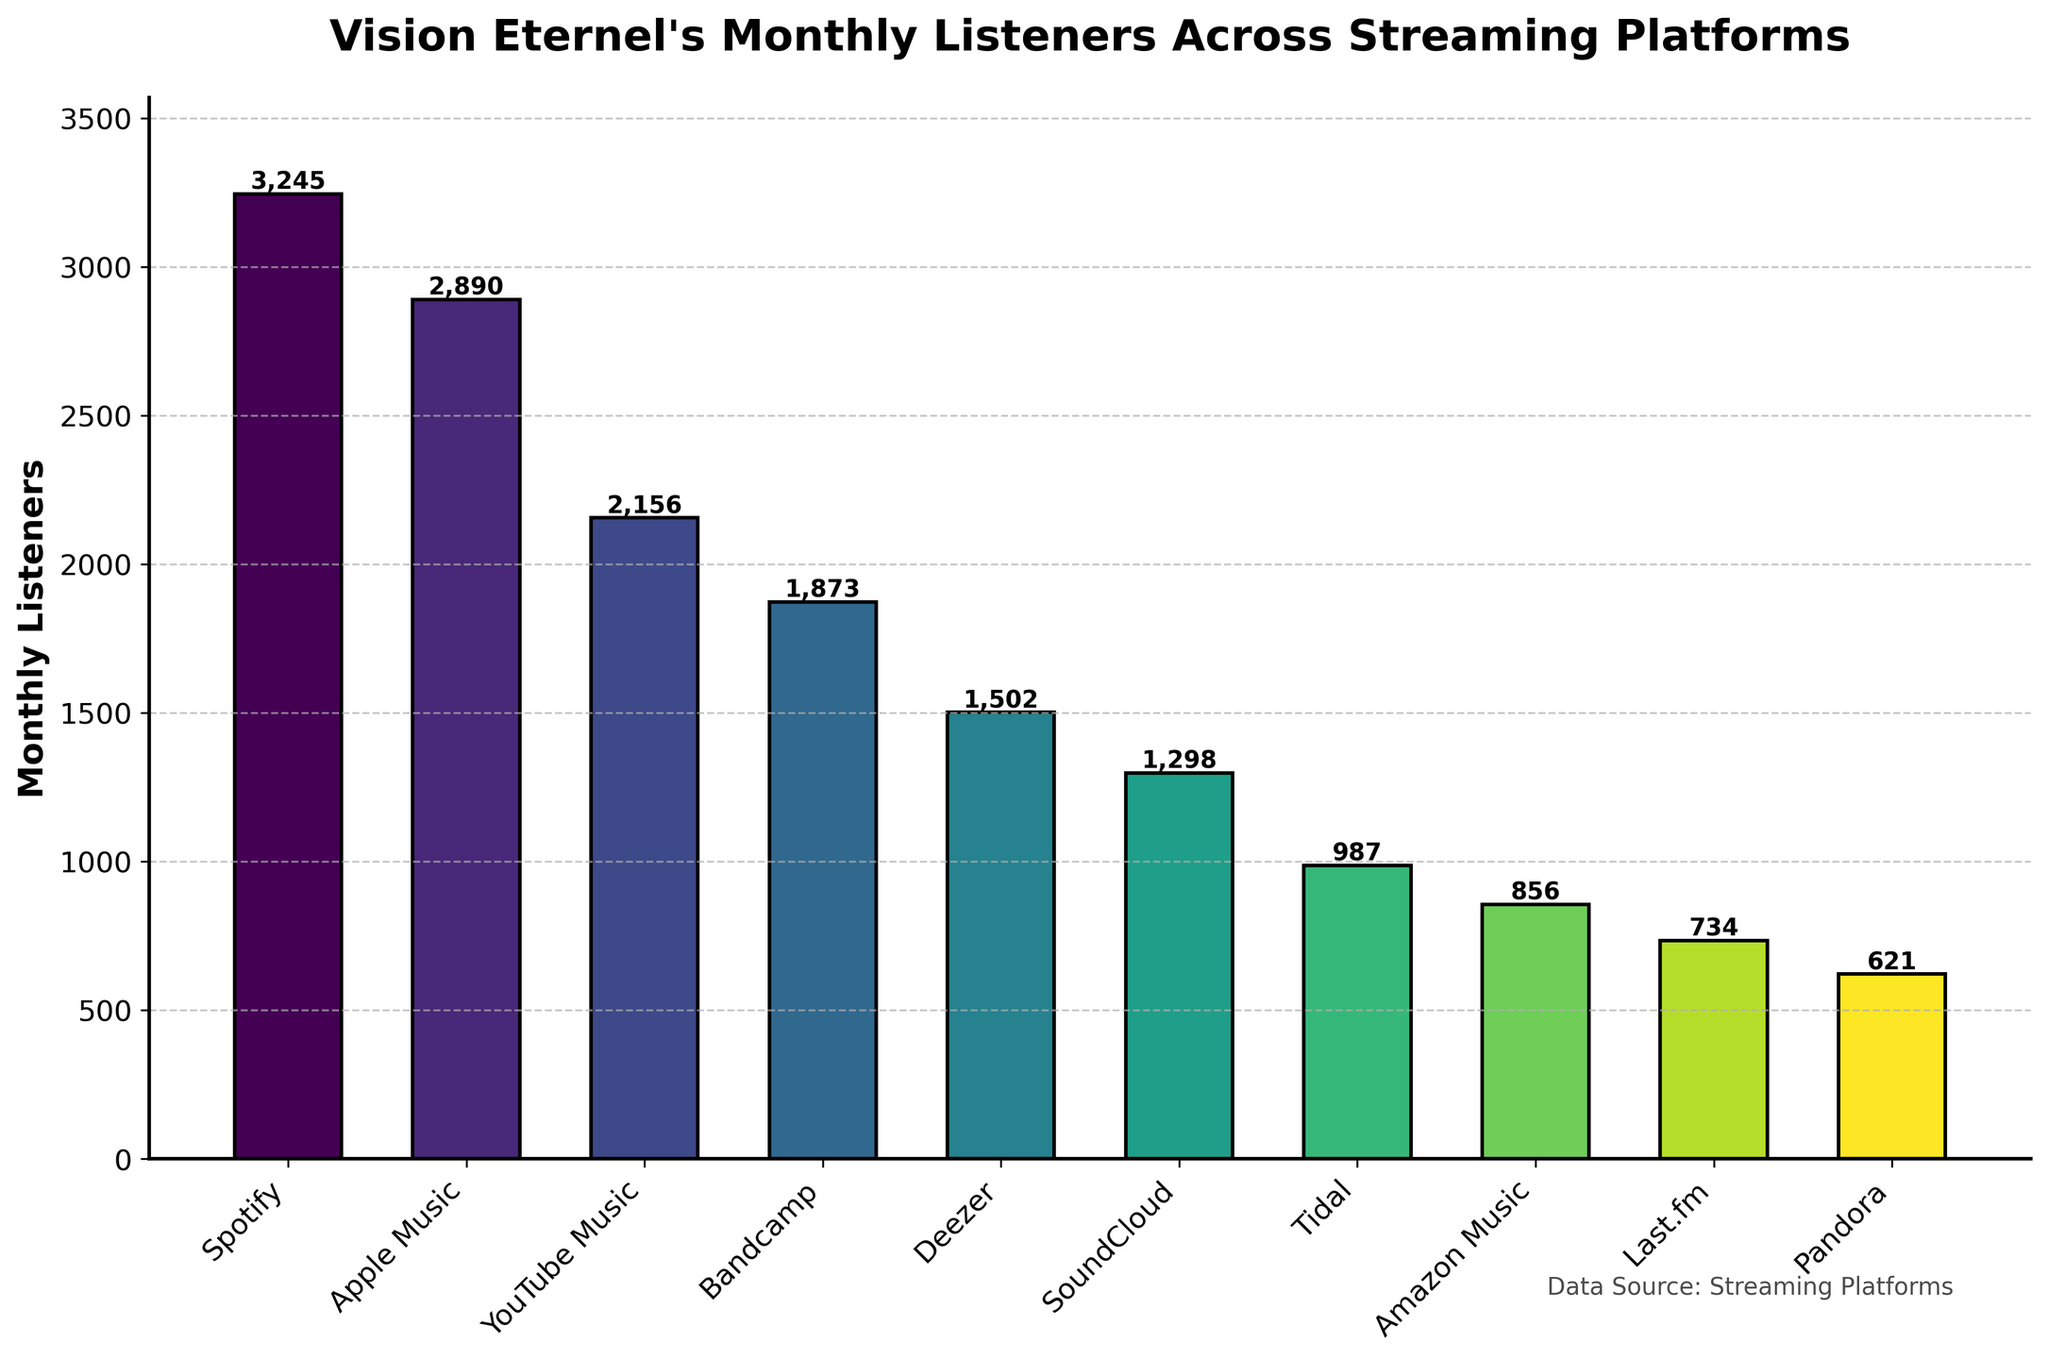Which platform has the most monthly listeners? By looking at the height of the bars in the chart, the bar representing Spotify is the tallest, which indicates that Spotify has the highest number of monthly listeners.
Answer: Spotify Which platform has fewer monthly listeners, Bandcamp or Deezer? By comparing the heights of the bars for Bandcamp and Deezer, it is observed that the Bandcamp bar is taller than the Deezer bar, meaning Bandcamp has more monthly listeners. Therefore, Deezer has fewer monthly listeners than Bandcamp.
Answer: Deezer What is the total number of monthly listeners for YouTube Music and Apple Music combined? To find the total, add the number of monthly listeners for YouTube Music (2156) and Apple Music (2890). The calculation is 2156 + 2890 = 5046.
Answer: 5046 What is the average number of monthly listeners across all platforms? To calculate the average, first find the sum of all monthly listeners, then divide by the number of platforms. Sum = 3245 + 2890 + 2156 + 1873 + 1502 + 1298 + 987 + 856 + 734 + 621 = 16762. There are 10 platforms, so the average is 16762 / 10 = 1676.2.
Answer: 1676.2 Is the number of monthly listeners for Amazon Music greater than for Last.fm? By comparing the heights of the bars for Amazon Music and Last.fm, it is observed that the Amazon Music bar is slightly taller than the Last.fm bar, meaning Amazon Music has more monthly listeners than Last.fm.
Answer: Yes Which platform has the least monthly listeners? By looking at the heights of all the bars, the shortest bar represents Pandora. This indicates that Pandora has the fewest monthly listeners.
Answer: Pandora What is the difference in monthly listeners between the platform with the most listeners and the platform with the fewest listeners? The platform with the most listeners is Spotify (3245), and the platform with the fewest listeners is Pandora (621). The difference is calculated as 3245 - 621 = 2624.
Answer: 2624 Arrange the platforms in descending order based on their monthly listeners. Based on the heights of the bars, the order from highest to lowest listeners is: Spotify (3245), Apple Music (2890), YouTube Music (2156), Bandcamp (1873), Deezer (1502), SoundCloud (1298), Tidal (987), Amazon Music (856), Last.fm (734), Pandora (621).
Answer: Spotify, Apple Music, YouTube Music, Bandcamp, Deezer, SoundCloud, Tidal, Amazon Music, Last.fm, Pandora What is the median number of monthly listeners? To find the median, list the numbers in ascending order: 621, 734, 856, 987, 1298, 1502, 1873, 2156, 2890, 3245. There are 10 numbers, the median is the average of the 5th and 6th numbers: (1298 + 1502) / 2 = 1400.
Answer: 1400 How many more monthly listeners does Spotify have compared to SoundCloud? The number of monthly listeners for Spotify is 3245 and for SoundCloud is 1298. The difference is calculated as 3245 - 1298 = 1947.
Answer: 1947 